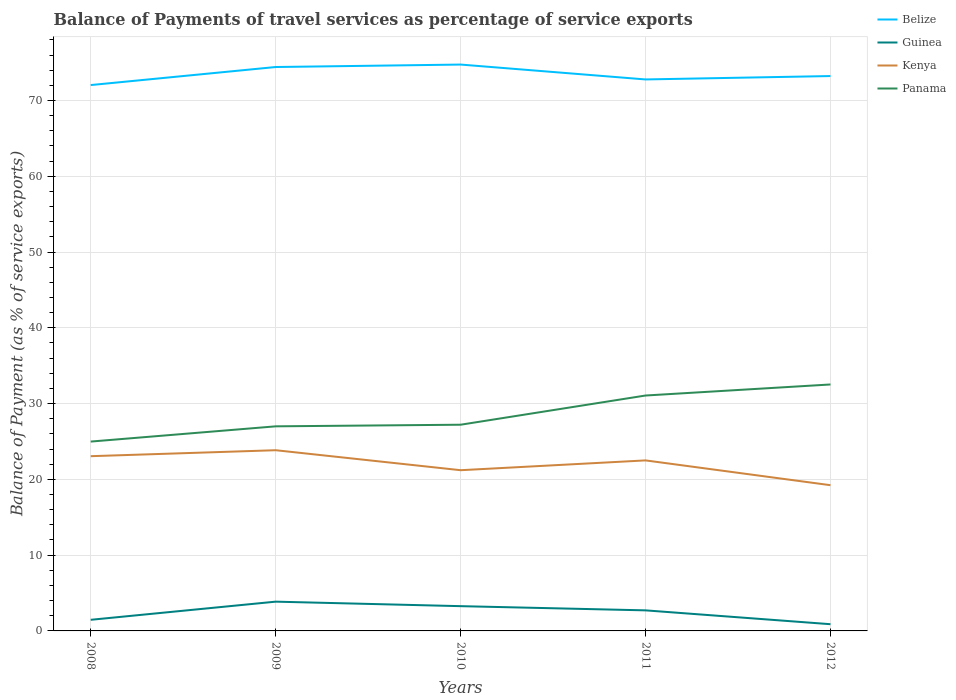How many different coloured lines are there?
Provide a succinct answer. 4. Does the line corresponding to Guinea intersect with the line corresponding to Kenya?
Keep it short and to the point. No. Across all years, what is the maximum balance of payments of travel services in Guinea?
Your answer should be very brief. 0.89. What is the total balance of payments of travel services in Kenya in the graph?
Ensure brevity in your answer.  3.83. What is the difference between the highest and the second highest balance of payments of travel services in Panama?
Keep it short and to the point. 7.54. What is the difference between the highest and the lowest balance of payments of travel services in Belize?
Provide a succinct answer. 2. How many years are there in the graph?
Your response must be concise. 5. What is the difference between two consecutive major ticks on the Y-axis?
Ensure brevity in your answer.  10. Are the values on the major ticks of Y-axis written in scientific E-notation?
Provide a short and direct response. No. Does the graph contain any zero values?
Make the answer very short. No. What is the title of the graph?
Give a very brief answer. Balance of Payments of travel services as percentage of service exports. Does "South Sudan" appear as one of the legend labels in the graph?
Give a very brief answer. No. What is the label or title of the Y-axis?
Provide a succinct answer. Balance of Payment (as % of service exports). What is the Balance of Payment (as % of service exports) in Belize in 2008?
Give a very brief answer. 72.03. What is the Balance of Payment (as % of service exports) in Guinea in 2008?
Provide a succinct answer. 1.47. What is the Balance of Payment (as % of service exports) in Kenya in 2008?
Offer a terse response. 23.06. What is the Balance of Payment (as % of service exports) of Panama in 2008?
Ensure brevity in your answer.  24.99. What is the Balance of Payment (as % of service exports) of Belize in 2009?
Ensure brevity in your answer.  74.42. What is the Balance of Payment (as % of service exports) in Guinea in 2009?
Make the answer very short. 3.86. What is the Balance of Payment (as % of service exports) in Kenya in 2009?
Offer a terse response. 23.85. What is the Balance of Payment (as % of service exports) in Panama in 2009?
Ensure brevity in your answer.  27. What is the Balance of Payment (as % of service exports) of Belize in 2010?
Offer a terse response. 74.74. What is the Balance of Payment (as % of service exports) in Guinea in 2010?
Your response must be concise. 3.27. What is the Balance of Payment (as % of service exports) in Kenya in 2010?
Make the answer very short. 21.21. What is the Balance of Payment (as % of service exports) in Panama in 2010?
Give a very brief answer. 27.21. What is the Balance of Payment (as % of service exports) in Belize in 2011?
Keep it short and to the point. 72.78. What is the Balance of Payment (as % of service exports) in Guinea in 2011?
Your answer should be compact. 2.71. What is the Balance of Payment (as % of service exports) in Kenya in 2011?
Provide a short and direct response. 22.5. What is the Balance of Payment (as % of service exports) in Panama in 2011?
Give a very brief answer. 31.06. What is the Balance of Payment (as % of service exports) of Belize in 2012?
Provide a short and direct response. 73.22. What is the Balance of Payment (as % of service exports) in Guinea in 2012?
Give a very brief answer. 0.89. What is the Balance of Payment (as % of service exports) in Kenya in 2012?
Your response must be concise. 19.23. What is the Balance of Payment (as % of service exports) in Panama in 2012?
Offer a very short reply. 32.52. Across all years, what is the maximum Balance of Payment (as % of service exports) of Belize?
Give a very brief answer. 74.74. Across all years, what is the maximum Balance of Payment (as % of service exports) in Guinea?
Your answer should be compact. 3.86. Across all years, what is the maximum Balance of Payment (as % of service exports) of Kenya?
Make the answer very short. 23.85. Across all years, what is the maximum Balance of Payment (as % of service exports) in Panama?
Provide a short and direct response. 32.52. Across all years, what is the minimum Balance of Payment (as % of service exports) of Belize?
Provide a short and direct response. 72.03. Across all years, what is the minimum Balance of Payment (as % of service exports) in Guinea?
Make the answer very short. 0.89. Across all years, what is the minimum Balance of Payment (as % of service exports) in Kenya?
Ensure brevity in your answer.  19.23. Across all years, what is the minimum Balance of Payment (as % of service exports) in Panama?
Your answer should be compact. 24.99. What is the total Balance of Payment (as % of service exports) in Belize in the graph?
Offer a terse response. 367.19. What is the total Balance of Payment (as % of service exports) of Guinea in the graph?
Offer a very short reply. 12.2. What is the total Balance of Payment (as % of service exports) of Kenya in the graph?
Ensure brevity in your answer.  109.85. What is the total Balance of Payment (as % of service exports) in Panama in the graph?
Offer a very short reply. 142.78. What is the difference between the Balance of Payment (as % of service exports) of Belize in 2008 and that in 2009?
Offer a terse response. -2.38. What is the difference between the Balance of Payment (as % of service exports) of Guinea in 2008 and that in 2009?
Provide a short and direct response. -2.39. What is the difference between the Balance of Payment (as % of service exports) of Kenya in 2008 and that in 2009?
Your answer should be compact. -0.79. What is the difference between the Balance of Payment (as % of service exports) in Panama in 2008 and that in 2009?
Offer a very short reply. -2.01. What is the difference between the Balance of Payment (as % of service exports) in Belize in 2008 and that in 2010?
Ensure brevity in your answer.  -2.71. What is the difference between the Balance of Payment (as % of service exports) in Guinea in 2008 and that in 2010?
Your answer should be very brief. -1.8. What is the difference between the Balance of Payment (as % of service exports) in Kenya in 2008 and that in 2010?
Offer a very short reply. 1.85. What is the difference between the Balance of Payment (as % of service exports) of Panama in 2008 and that in 2010?
Your response must be concise. -2.22. What is the difference between the Balance of Payment (as % of service exports) in Belize in 2008 and that in 2011?
Provide a short and direct response. -0.74. What is the difference between the Balance of Payment (as % of service exports) in Guinea in 2008 and that in 2011?
Offer a very short reply. -1.25. What is the difference between the Balance of Payment (as % of service exports) in Kenya in 2008 and that in 2011?
Provide a short and direct response. 0.56. What is the difference between the Balance of Payment (as % of service exports) of Panama in 2008 and that in 2011?
Your answer should be compact. -6.08. What is the difference between the Balance of Payment (as % of service exports) of Belize in 2008 and that in 2012?
Keep it short and to the point. -1.19. What is the difference between the Balance of Payment (as % of service exports) in Guinea in 2008 and that in 2012?
Your answer should be compact. 0.58. What is the difference between the Balance of Payment (as % of service exports) of Kenya in 2008 and that in 2012?
Your answer should be very brief. 3.83. What is the difference between the Balance of Payment (as % of service exports) of Panama in 2008 and that in 2012?
Make the answer very short. -7.54. What is the difference between the Balance of Payment (as % of service exports) of Belize in 2009 and that in 2010?
Your answer should be compact. -0.32. What is the difference between the Balance of Payment (as % of service exports) in Guinea in 2009 and that in 2010?
Keep it short and to the point. 0.59. What is the difference between the Balance of Payment (as % of service exports) of Kenya in 2009 and that in 2010?
Give a very brief answer. 2.64. What is the difference between the Balance of Payment (as % of service exports) in Panama in 2009 and that in 2010?
Make the answer very short. -0.21. What is the difference between the Balance of Payment (as % of service exports) in Belize in 2009 and that in 2011?
Offer a very short reply. 1.64. What is the difference between the Balance of Payment (as % of service exports) in Guinea in 2009 and that in 2011?
Your response must be concise. 1.15. What is the difference between the Balance of Payment (as % of service exports) of Kenya in 2009 and that in 2011?
Your response must be concise. 1.34. What is the difference between the Balance of Payment (as % of service exports) of Panama in 2009 and that in 2011?
Provide a short and direct response. -4.07. What is the difference between the Balance of Payment (as % of service exports) in Belize in 2009 and that in 2012?
Provide a short and direct response. 1.19. What is the difference between the Balance of Payment (as % of service exports) of Guinea in 2009 and that in 2012?
Provide a succinct answer. 2.98. What is the difference between the Balance of Payment (as % of service exports) in Kenya in 2009 and that in 2012?
Ensure brevity in your answer.  4.62. What is the difference between the Balance of Payment (as % of service exports) of Panama in 2009 and that in 2012?
Your answer should be very brief. -5.52. What is the difference between the Balance of Payment (as % of service exports) in Belize in 2010 and that in 2011?
Offer a very short reply. 1.96. What is the difference between the Balance of Payment (as % of service exports) in Guinea in 2010 and that in 2011?
Provide a short and direct response. 0.55. What is the difference between the Balance of Payment (as % of service exports) in Kenya in 2010 and that in 2011?
Keep it short and to the point. -1.29. What is the difference between the Balance of Payment (as % of service exports) in Panama in 2010 and that in 2011?
Provide a short and direct response. -3.85. What is the difference between the Balance of Payment (as % of service exports) of Belize in 2010 and that in 2012?
Offer a terse response. 1.52. What is the difference between the Balance of Payment (as % of service exports) in Guinea in 2010 and that in 2012?
Offer a very short reply. 2.38. What is the difference between the Balance of Payment (as % of service exports) of Kenya in 2010 and that in 2012?
Provide a short and direct response. 1.98. What is the difference between the Balance of Payment (as % of service exports) in Panama in 2010 and that in 2012?
Give a very brief answer. -5.31. What is the difference between the Balance of Payment (as % of service exports) of Belize in 2011 and that in 2012?
Provide a short and direct response. -0.45. What is the difference between the Balance of Payment (as % of service exports) in Guinea in 2011 and that in 2012?
Provide a short and direct response. 1.83. What is the difference between the Balance of Payment (as % of service exports) in Kenya in 2011 and that in 2012?
Offer a terse response. 3.27. What is the difference between the Balance of Payment (as % of service exports) of Panama in 2011 and that in 2012?
Give a very brief answer. -1.46. What is the difference between the Balance of Payment (as % of service exports) in Belize in 2008 and the Balance of Payment (as % of service exports) in Guinea in 2009?
Provide a short and direct response. 68.17. What is the difference between the Balance of Payment (as % of service exports) in Belize in 2008 and the Balance of Payment (as % of service exports) in Kenya in 2009?
Make the answer very short. 48.19. What is the difference between the Balance of Payment (as % of service exports) of Belize in 2008 and the Balance of Payment (as % of service exports) of Panama in 2009?
Give a very brief answer. 45.04. What is the difference between the Balance of Payment (as % of service exports) in Guinea in 2008 and the Balance of Payment (as % of service exports) in Kenya in 2009?
Offer a very short reply. -22.38. What is the difference between the Balance of Payment (as % of service exports) of Guinea in 2008 and the Balance of Payment (as % of service exports) of Panama in 2009?
Your answer should be compact. -25.53. What is the difference between the Balance of Payment (as % of service exports) of Kenya in 2008 and the Balance of Payment (as % of service exports) of Panama in 2009?
Make the answer very short. -3.94. What is the difference between the Balance of Payment (as % of service exports) in Belize in 2008 and the Balance of Payment (as % of service exports) in Guinea in 2010?
Make the answer very short. 68.77. What is the difference between the Balance of Payment (as % of service exports) in Belize in 2008 and the Balance of Payment (as % of service exports) in Kenya in 2010?
Your answer should be compact. 50.82. What is the difference between the Balance of Payment (as % of service exports) of Belize in 2008 and the Balance of Payment (as % of service exports) of Panama in 2010?
Make the answer very short. 44.82. What is the difference between the Balance of Payment (as % of service exports) in Guinea in 2008 and the Balance of Payment (as % of service exports) in Kenya in 2010?
Give a very brief answer. -19.74. What is the difference between the Balance of Payment (as % of service exports) of Guinea in 2008 and the Balance of Payment (as % of service exports) of Panama in 2010?
Make the answer very short. -25.74. What is the difference between the Balance of Payment (as % of service exports) of Kenya in 2008 and the Balance of Payment (as % of service exports) of Panama in 2010?
Offer a terse response. -4.15. What is the difference between the Balance of Payment (as % of service exports) of Belize in 2008 and the Balance of Payment (as % of service exports) of Guinea in 2011?
Provide a short and direct response. 69.32. What is the difference between the Balance of Payment (as % of service exports) in Belize in 2008 and the Balance of Payment (as % of service exports) in Kenya in 2011?
Keep it short and to the point. 49.53. What is the difference between the Balance of Payment (as % of service exports) in Belize in 2008 and the Balance of Payment (as % of service exports) in Panama in 2011?
Your response must be concise. 40.97. What is the difference between the Balance of Payment (as % of service exports) in Guinea in 2008 and the Balance of Payment (as % of service exports) in Kenya in 2011?
Provide a succinct answer. -21.04. What is the difference between the Balance of Payment (as % of service exports) in Guinea in 2008 and the Balance of Payment (as % of service exports) in Panama in 2011?
Give a very brief answer. -29.6. What is the difference between the Balance of Payment (as % of service exports) in Kenya in 2008 and the Balance of Payment (as % of service exports) in Panama in 2011?
Offer a terse response. -8.01. What is the difference between the Balance of Payment (as % of service exports) of Belize in 2008 and the Balance of Payment (as % of service exports) of Guinea in 2012?
Offer a very short reply. 71.15. What is the difference between the Balance of Payment (as % of service exports) in Belize in 2008 and the Balance of Payment (as % of service exports) in Kenya in 2012?
Keep it short and to the point. 52.8. What is the difference between the Balance of Payment (as % of service exports) of Belize in 2008 and the Balance of Payment (as % of service exports) of Panama in 2012?
Make the answer very short. 39.51. What is the difference between the Balance of Payment (as % of service exports) of Guinea in 2008 and the Balance of Payment (as % of service exports) of Kenya in 2012?
Offer a very short reply. -17.76. What is the difference between the Balance of Payment (as % of service exports) of Guinea in 2008 and the Balance of Payment (as % of service exports) of Panama in 2012?
Your response must be concise. -31.06. What is the difference between the Balance of Payment (as % of service exports) of Kenya in 2008 and the Balance of Payment (as % of service exports) of Panama in 2012?
Provide a succinct answer. -9.46. What is the difference between the Balance of Payment (as % of service exports) in Belize in 2009 and the Balance of Payment (as % of service exports) in Guinea in 2010?
Offer a terse response. 71.15. What is the difference between the Balance of Payment (as % of service exports) in Belize in 2009 and the Balance of Payment (as % of service exports) in Kenya in 2010?
Your response must be concise. 53.21. What is the difference between the Balance of Payment (as % of service exports) of Belize in 2009 and the Balance of Payment (as % of service exports) of Panama in 2010?
Offer a very short reply. 47.21. What is the difference between the Balance of Payment (as % of service exports) of Guinea in 2009 and the Balance of Payment (as % of service exports) of Kenya in 2010?
Provide a succinct answer. -17.35. What is the difference between the Balance of Payment (as % of service exports) in Guinea in 2009 and the Balance of Payment (as % of service exports) in Panama in 2010?
Provide a short and direct response. -23.35. What is the difference between the Balance of Payment (as % of service exports) in Kenya in 2009 and the Balance of Payment (as % of service exports) in Panama in 2010?
Your answer should be very brief. -3.36. What is the difference between the Balance of Payment (as % of service exports) of Belize in 2009 and the Balance of Payment (as % of service exports) of Guinea in 2011?
Offer a terse response. 71.7. What is the difference between the Balance of Payment (as % of service exports) in Belize in 2009 and the Balance of Payment (as % of service exports) in Kenya in 2011?
Make the answer very short. 51.91. What is the difference between the Balance of Payment (as % of service exports) in Belize in 2009 and the Balance of Payment (as % of service exports) in Panama in 2011?
Provide a short and direct response. 43.35. What is the difference between the Balance of Payment (as % of service exports) of Guinea in 2009 and the Balance of Payment (as % of service exports) of Kenya in 2011?
Keep it short and to the point. -18.64. What is the difference between the Balance of Payment (as % of service exports) of Guinea in 2009 and the Balance of Payment (as % of service exports) of Panama in 2011?
Provide a short and direct response. -27.2. What is the difference between the Balance of Payment (as % of service exports) in Kenya in 2009 and the Balance of Payment (as % of service exports) in Panama in 2011?
Your answer should be compact. -7.22. What is the difference between the Balance of Payment (as % of service exports) of Belize in 2009 and the Balance of Payment (as % of service exports) of Guinea in 2012?
Provide a short and direct response. 73.53. What is the difference between the Balance of Payment (as % of service exports) of Belize in 2009 and the Balance of Payment (as % of service exports) of Kenya in 2012?
Offer a very short reply. 55.19. What is the difference between the Balance of Payment (as % of service exports) in Belize in 2009 and the Balance of Payment (as % of service exports) in Panama in 2012?
Provide a succinct answer. 41.89. What is the difference between the Balance of Payment (as % of service exports) in Guinea in 2009 and the Balance of Payment (as % of service exports) in Kenya in 2012?
Ensure brevity in your answer.  -15.37. What is the difference between the Balance of Payment (as % of service exports) in Guinea in 2009 and the Balance of Payment (as % of service exports) in Panama in 2012?
Provide a short and direct response. -28.66. What is the difference between the Balance of Payment (as % of service exports) in Kenya in 2009 and the Balance of Payment (as % of service exports) in Panama in 2012?
Ensure brevity in your answer.  -8.68. What is the difference between the Balance of Payment (as % of service exports) of Belize in 2010 and the Balance of Payment (as % of service exports) of Guinea in 2011?
Offer a very short reply. 72.03. What is the difference between the Balance of Payment (as % of service exports) in Belize in 2010 and the Balance of Payment (as % of service exports) in Kenya in 2011?
Provide a short and direct response. 52.24. What is the difference between the Balance of Payment (as % of service exports) in Belize in 2010 and the Balance of Payment (as % of service exports) in Panama in 2011?
Provide a short and direct response. 43.68. What is the difference between the Balance of Payment (as % of service exports) in Guinea in 2010 and the Balance of Payment (as % of service exports) in Kenya in 2011?
Keep it short and to the point. -19.23. What is the difference between the Balance of Payment (as % of service exports) of Guinea in 2010 and the Balance of Payment (as % of service exports) of Panama in 2011?
Offer a terse response. -27.8. What is the difference between the Balance of Payment (as % of service exports) in Kenya in 2010 and the Balance of Payment (as % of service exports) in Panama in 2011?
Provide a succinct answer. -9.85. What is the difference between the Balance of Payment (as % of service exports) in Belize in 2010 and the Balance of Payment (as % of service exports) in Guinea in 2012?
Keep it short and to the point. 73.85. What is the difference between the Balance of Payment (as % of service exports) in Belize in 2010 and the Balance of Payment (as % of service exports) in Kenya in 2012?
Offer a very short reply. 55.51. What is the difference between the Balance of Payment (as % of service exports) in Belize in 2010 and the Balance of Payment (as % of service exports) in Panama in 2012?
Keep it short and to the point. 42.22. What is the difference between the Balance of Payment (as % of service exports) of Guinea in 2010 and the Balance of Payment (as % of service exports) of Kenya in 2012?
Offer a terse response. -15.96. What is the difference between the Balance of Payment (as % of service exports) in Guinea in 2010 and the Balance of Payment (as % of service exports) in Panama in 2012?
Offer a very short reply. -29.25. What is the difference between the Balance of Payment (as % of service exports) of Kenya in 2010 and the Balance of Payment (as % of service exports) of Panama in 2012?
Offer a terse response. -11.31. What is the difference between the Balance of Payment (as % of service exports) of Belize in 2011 and the Balance of Payment (as % of service exports) of Guinea in 2012?
Your answer should be very brief. 71.89. What is the difference between the Balance of Payment (as % of service exports) in Belize in 2011 and the Balance of Payment (as % of service exports) in Kenya in 2012?
Your response must be concise. 53.55. What is the difference between the Balance of Payment (as % of service exports) of Belize in 2011 and the Balance of Payment (as % of service exports) of Panama in 2012?
Give a very brief answer. 40.25. What is the difference between the Balance of Payment (as % of service exports) of Guinea in 2011 and the Balance of Payment (as % of service exports) of Kenya in 2012?
Your answer should be compact. -16.52. What is the difference between the Balance of Payment (as % of service exports) in Guinea in 2011 and the Balance of Payment (as % of service exports) in Panama in 2012?
Give a very brief answer. -29.81. What is the difference between the Balance of Payment (as % of service exports) in Kenya in 2011 and the Balance of Payment (as % of service exports) in Panama in 2012?
Give a very brief answer. -10.02. What is the average Balance of Payment (as % of service exports) in Belize per year?
Your answer should be very brief. 73.44. What is the average Balance of Payment (as % of service exports) in Guinea per year?
Provide a succinct answer. 2.44. What is the average Balance of Payment (as % of service exports) of Kenya per year?
Ensure brevity in your answer.  21.97. What is the average Balance of Payment (as % of service exports) of Panama per year?
Your answer should be compact. 28.56. In the year 2008, what is the difference between the Balance of Payment (as % of service exports) of Belize and Balance of Payment (as % of service exports) of Guinea?
Give a very brief answer. 70.57. In the year 2008, what is the difference between the Balance of Payment (as % of service exports) of Belize and Balance of Payment (as % of service exports) of Kenya?
Give a very brief answer. 48.98. In the year 2008, what is the difference between the Balance of Payment (as % of service exports) in Belize and Balance of Payment (as % of service exports) in Panama?
Ensure brevity in your answer.  47.05. In the year 2008, what is the difference between the Balance of Payment (as % of service exports) in Guinea and Balance of Payment (as % of service exports) in Kenya?
Ensure brevity in your answer.  -21.59. In the year 2008, what is the difference between the Balance of Payment (as % of service exports) of Guinea and Balance of Payment (as % of service exports) of Panama?
Give a very brief answer. -23.52. In the year 2008, what is the difference between the Balance of Payment (as % of service exports) in Kenya and Balance of Payment (as % of service exports) in Panama?
Offer a very short reply. -1.93. In the year 2009, what is the difference between the Balance of Payment (as % of service exports) in Belize and Balance of Payment (as % of service exports) in Guinea?
Make the answer very short. 70.55. In the year 2009, what is the difference between the Balance of Payment (as % of service exports) in Belize and Balance of Payment (as % of service exports) in Kenya?
Offer a very short reply. 50.57. In the year 2009, what is the difference between the Balance of Payment (as % of service exports) in Belize and Balance of Payment (as % of service exports) in Panama?
Ensure brevity in your answer.  47.42. In the year 2009, what is the difference between the Balance of Payment (as % of service exports) in Guinea and Balance of Payment (as % of service exports) in Kenya?
Give a very brief answer. -19.99. In the year 2009, what is the difference between the Balance of Payment (as % of service exports) in Guinea and Balance of Payment (as % of service exports) in Panama?
Make the answer very short. -23.14. In the year 2009, what is the difference between the Balance of Payment (as % of service exports) of Kenya and Balance of Payment (as % of service exports) of Panama?
Your answer should be very brief. -3.15. In the year 2010, what is the difference between the Balance of Payment (as % of service exports) in Belize and Balance of Payment (as % of service exports) in Guinea?
Offer a terse response. 71.47. In the year 2010, what is the difference between the Balance of Payment (as % of service exports) in Belize and Balance of Payment (as % of service exports) in Kenya?
Give a very brief answer. 53.53. In the year 2010, what is the difference between the Balance of Payment (as % of service exports) in Belize and Balance of Payment (as % of service exports) in Panama?
Your answer should be very brief. 47.53. In the year 2010, what is the difference between the Balance of Payment (as % of service exports) of Guinea and Balance of Payment (as % of service exports) of Kenya?
Offer a very short reply. -17.94. In the year 2010, what is the difference between the Balance of Payment (as % of service exports) in Guinea and Balance of Payment (as % of service exports) in Panama?
Provide a succinct answer. -23.94. In the year 2010, what is the difference between the Balance of Payment (as % of service exports) in Kenya and Balance of Payment (as % of service exports) in Panama?
Offer a terse response. -6. In the year 2011, what is the difference between the Balance of Payment (as % of service exports) in Belize and Balance of Payment (as % of service exports) in Guinea?
Your answer should be very brief. 70.06. In the year 2011, what is the difference between the Balance of Payment (as % of service exports) in Belize and Balance of Payment (as % of service exports) in Kenya?
Make the answer very short. 50.27. In the year 2011, what is the difference between the Balance of Payment (as % of service exports) of Belize and Balance of Payment (as % of service exports) of Panama?
Your answer should be very brief. 41.71. In the year 2011, what is the difference between the Balance of Payment (as % of service exports) in Guinea and Balance of Payment (as % of service exports) in Kenya?
Make the answer very short. -19.79. In the year 2011, what is the difference between the Balance of Payment (as % of service exports) of Guinea and Balance of Payment (as % of service exports) of Panama?
Make the answer very short. -28.35. In the year 2011, what is the difference between the Balance of Payment (as % of service exports) in Kenya and Balance of Payment (as % of service exports) in Panama?
Provide a short and direct response. -8.56. In the year 2012, what is the difference between the Balance of Payment (as % of service exports) of Belize and Balance of Payment (as % of service exports) of Guinea?
Your answer should be very brief. 72.34. In the year 2012, what is the difference between the Balance of Payment (as % of service exports) in Belize and Balance of Payment (as % of service exports) in Kenya?
Offer a terse response. 53.99. In the year 2012, what is the difference between the Balance of Payment (as % of service exports) of Belize and Balance of Payment (as % of service exports) of Panama?
Offer a very short reply. 40.7. In the year 2012, what is the difference between the Balance of Payment (as % of service exports) in Guinea and Balance of Payment (as % of service exports) in Kenya?
Your answer should be compact. -18.34. In the year 2012, what is the difference between the Balance of Payment (as % of service exports) in Guinea and Balance of Payment (as % of service exports) in Panama?
Provide a succinct answer. -31.64. In the year 2012, what is the difference between the Balance of Payment (as % of service exports) in Kenya and Balance of Payment (as % of service exports) in Panama?
Provide a short and direct response. -13.29. What is the ratio of the Balance of Payment (as % of service exports) of Guinea in 2008 to that in 2009?
Ensure brevity in your answer.  0.38. What is the ratio of the Balance of Payment (as % of service exports) of Panama in 2008 to that in 2009?
Your answer should be very brief. 0.93. What is the ratio of the Balance of Payment (as % of service exports) in Belize in 2008 to that in 2010?
Make the answer very short. 0.96. What is the ratio of the Balance of Payment (as % of service exports) in Guinea in 2008 to that in 2010?
Provide a succinct answer. 0.45. What is the ratio of the Balance of Payment (as % of service exports) in Kenya in 2008 to that in 2010?
Ensure brevity in your answer.  1.09. What is the ratio of the Balance of Payment (as % of service exports) of Panama in 2008 to that in 2010?
Offer a very short reply. 0.92. What is the ratio of the Balance of Payment (as % of service exports) of Belize in 2008 to that in 2011?
Your response must be concise. 0.99. What is the ratio of the Balance of Payment (as % of service exports) in Guinea in 2008 to that in 2011?
Provide a succinct answer. 0.54. What is the ratio of the Balance of Payment (as % of service exports) of Kenya in 2008 to that in 2011?
Your answer should be very brief. 1.02. What is the ratio of the Balance of Payment (as % of service exports) in Panama in 2008 to that in 2011?
Make the answer very short. 0.8. What is the ratio of the Balance of Payment (as % of service exports) of Belize in 2008 to that in 2012?
Your answer should be compact. 0.98. What is the ratio of the Balance of Payment (as % of service exports) of Guinea in 2008 to that in 2012?
Provide a short and direct response. 1.66. What is the ratio of the Balance of Payment (as % of service exports) of Kenya in 2008 to that in 2012?
Your answer should be compact. 1.2. What is the ratio of the Balance of Payment (as % of service exports) in Panama in 2008 to that in 2012?
Provide a succinct answer. 0.77. What is the ratio of the Balance of Payment (as % of service exports) in Belize in 2009 to that in 2010?
Offer a very short reply. 1. What is the ratio of the Balance of Payment (as % of service exports) of Guinea in 2009 to that in 2010?
Provide a succinct answer. 1.18. What is the ratio of the Balance of Payment (as % of service exports) in Kenya in 2009 to that in 2010?
Your response must be concise. 1.12. What is the ratio of the Balance of Payment (as % of service exports) in Belize in 2009 to that in 2011?
Provide a succinct answer. 1.02. What is the ratio of the Balance of Payment (as % of service exports) in Guinea in 2009 to that in 2011?
Ensure brevity in your answer.  1.42. What is the ratio of the Balance of Payment (as % of service exports) of Kenya in 2009 to that in 2011?
Your answer should be compact. 1.06. What is the ratio of the Balance of Payment (as % of service exports) in Panama in 2009 to that in 2011?
Give a very brief answer. 0.87. What is the ratio of the Balance of Payment (as % of service exports) in Belize in 2009 to that in 2012?
Offer a very short reply. 1.02. What is the ratio of the Balance of Payment (as % of service exports) in Guinea in 2009 to that in 2012?
Make the answer very short. 4.36. What is the ratio of the Balance of Payment (as % of service exports) in Kenya in 2009 to that in 2012?
Your response must be concise. 1.24. What is the ratio of the Balance of Payment (as % of service exports) of Panama in 2009 to that in 2012?
Your answer should be compact. 0.83. What is the ratio of the Balance of Payment (as % of service exports) of Belize in 2010 to that in 2011?
Provide a short and direct response. 1.03. What is the ratio of the Balance of Payment (as % of service exports) of Guinea in 2010 to that in 2011?
Provide a short and direct response. 1.2. What is the ratio of the Balance of Payment (as % of service exports) in Kenya in 2010 to that in 2011?
Ensure brevity in your answer.  0.94. What is the ratio of the Balance of Payment (as % of service exports) in Panama in 2010 to that in 2011?
Offer a terse response. 0.88. What is the ratio of the Balance of Payment (as % of service exports) in Belize in 2010 to that in 2012?
Your answer should be compact. 1.02. What is the ratio of the Balance of Payment (as % of service exports) of Guinea in 2010 to that in 2012?
Make the answer very short. 3.69. What is the ratio of the Balance of Payment (as % of service exports) in Kenya in 2010 to that in 2012?
Your answer should be very brief. 1.1. What is the ratio of the Balance of Payment (as % of service exports) in Panama in 2010 to that in 2012?
Offer a very short reply. 0.84. What is the ratio of the Balance of Payment (as % of service exports) in Belize in 2011 to that in 2012?
Keep it short and to the point. 0.99. What is the ratio of the Balance of Payment (as % of service exports) in Guinea in 2011 to that in 2012?
Your response must be concise. 3.06. What is the ratio of the Balance of Payment (as % of service exports) of Kenya in 2011 to that in 2012?
Give a very brief answer. 1.17. What is the ratio of the Balance of Payment (as % of service exports) of Panama in 2011 to that in 2012?
Offer a very short reply. 0.96. What is the difference between the highest and the second highest Balance of Payment (as % of service exports) in Belize?
Provide a succinct answer. 0.32. What is the difference between the highest and the second highest Balance of Payment (as % of service exports) of Guinea?
Your answer should be compact. 0.59. What is the difference between the highest and the second highest Balance of Payment (as % of service exports) in Kenya?
Keep it short and to the point. 0.79. What is the difference between the highest and the second highest Balance of Payment (as % of service exports) of Panama?
Your answer should be compact. 1.46. What is the difference between the highest and the lowest Balance of Payment (as % of service exports) of Belize?
Provide a succinct answer. 2.71. What is the difference between the highest and the lowest Balance of Payment (as % of service exports) of Guinea?
Offer a terse response. 2.98. What is the difference between the highest and the lowest Balance of Payment (as % of service exports) in Kenya?
Offer a very short reply. 4.62. What is the difference between the highest and the lowest Balance of Payment (as % of service exports) in Panama?
Make the answer very short. 7.54. 